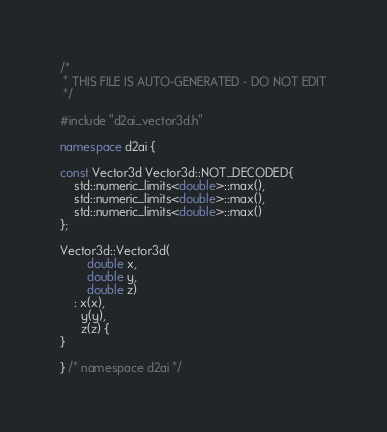<code> <loc_0><loc_0><loc_500><loc_500><_C++_>/*
 * THIS FILE IS AUTO-GENERATED - DO NOT EDIT
 */

#include "d2ai_vector3d.h"

namespace d2ai {

const Vector3d Vector3d::NOT_DECODED{
    std::numeric_limits<double>::max(),
    std::numeric_limits<double>::max(),
    std::numeric_limits<double>::max()
};

Vector3d::Vector3d(
        double x,
        double y,
        double z)
    : x(x),
      y(y),
      z(z) {
}

} /* namespace d2ai */
</code> 